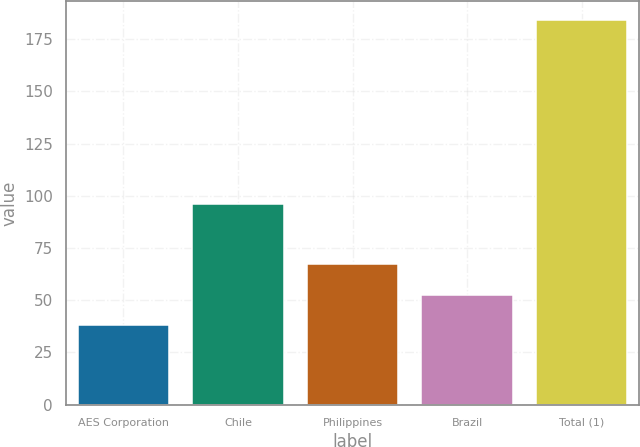Convert chart to OTSL. <chart><loc_0><loc_0><loc_500><loc_500><bar_chart><fcel>AES Corporation<fcel>Chile<fcel>Philippines<fcel>Brazil<fcel>Total (1)<nl><fcel>38<fcel>96<fcel>67.2<fcel>52.6<fcel>184<nl></chart> 